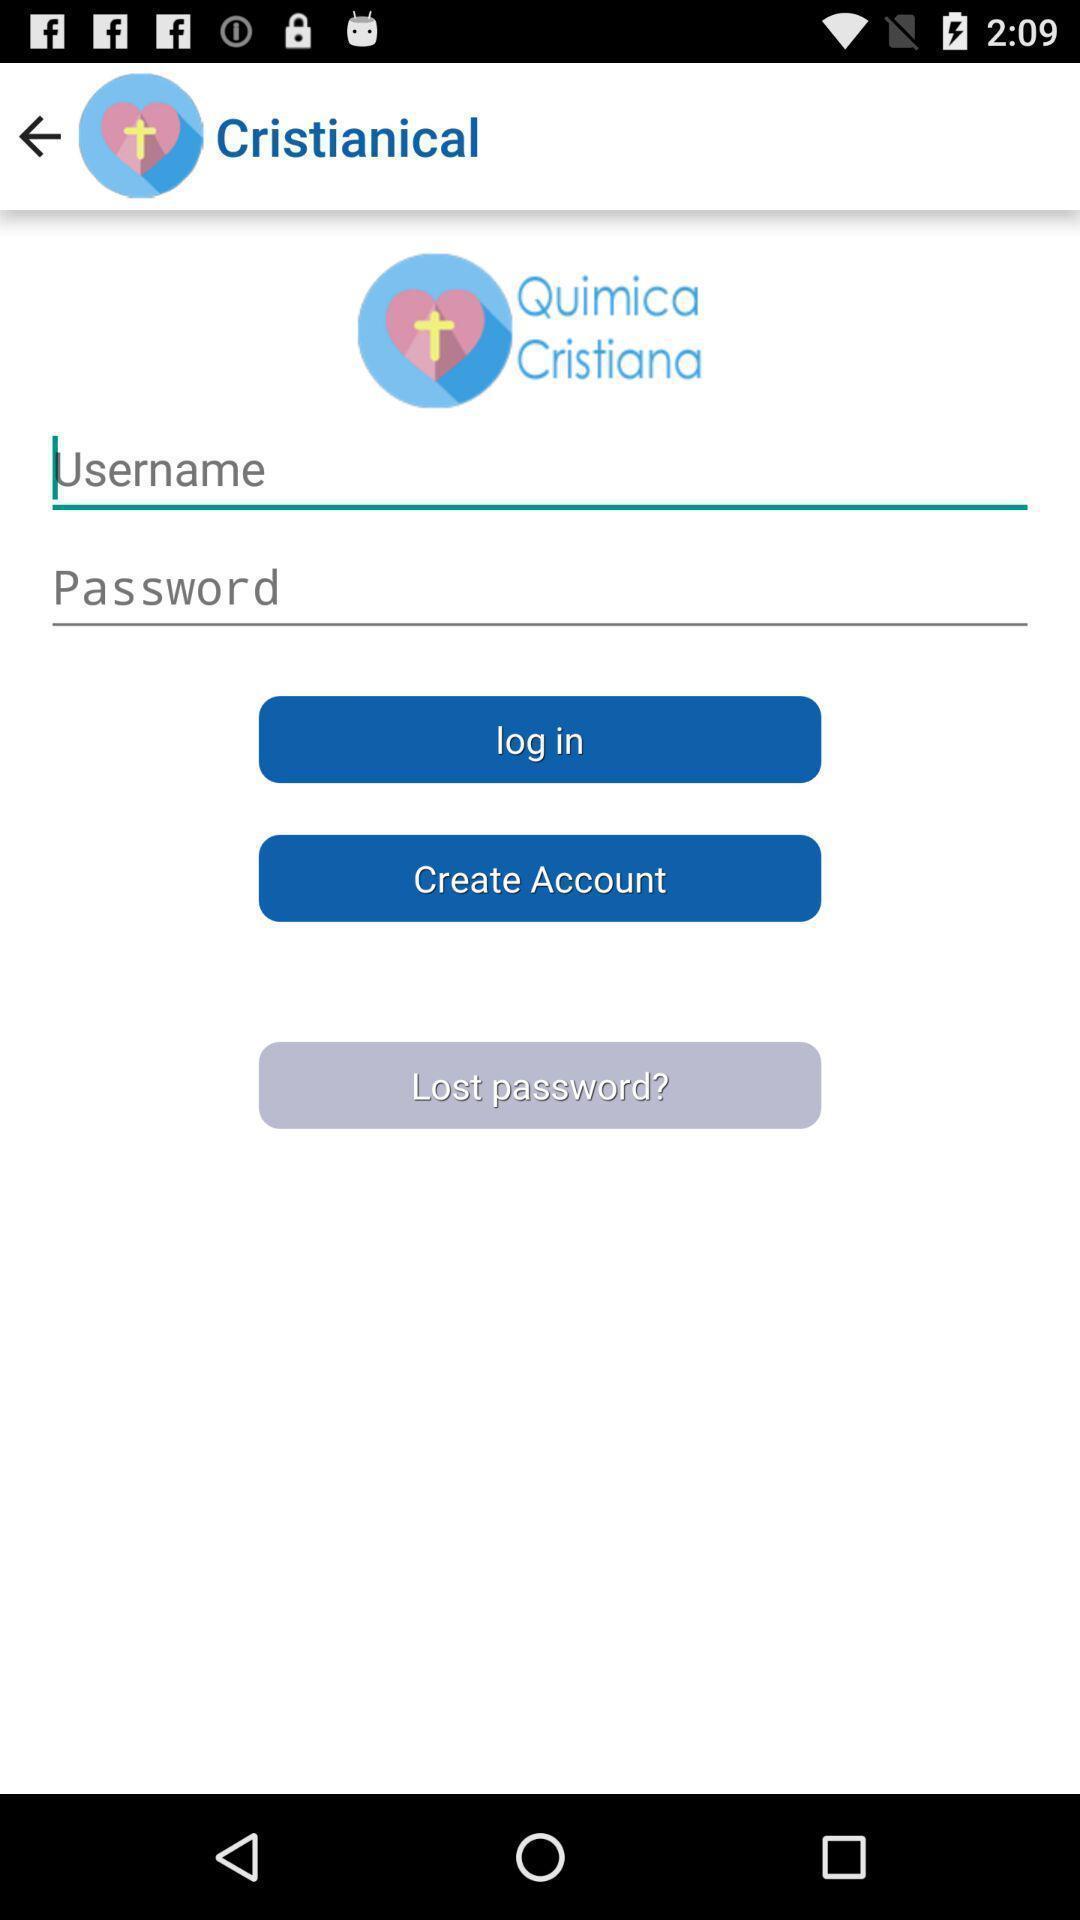What can you discern from this picture? Screen displaying the login page. 